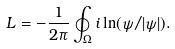<formula> <loc_0><loc_0><loc_500><loc_500>L = - \frac { 1 } { 2 \pi } \oint _ { \Omega } i \ln ( \psi / | \psi | ) .</formula> 